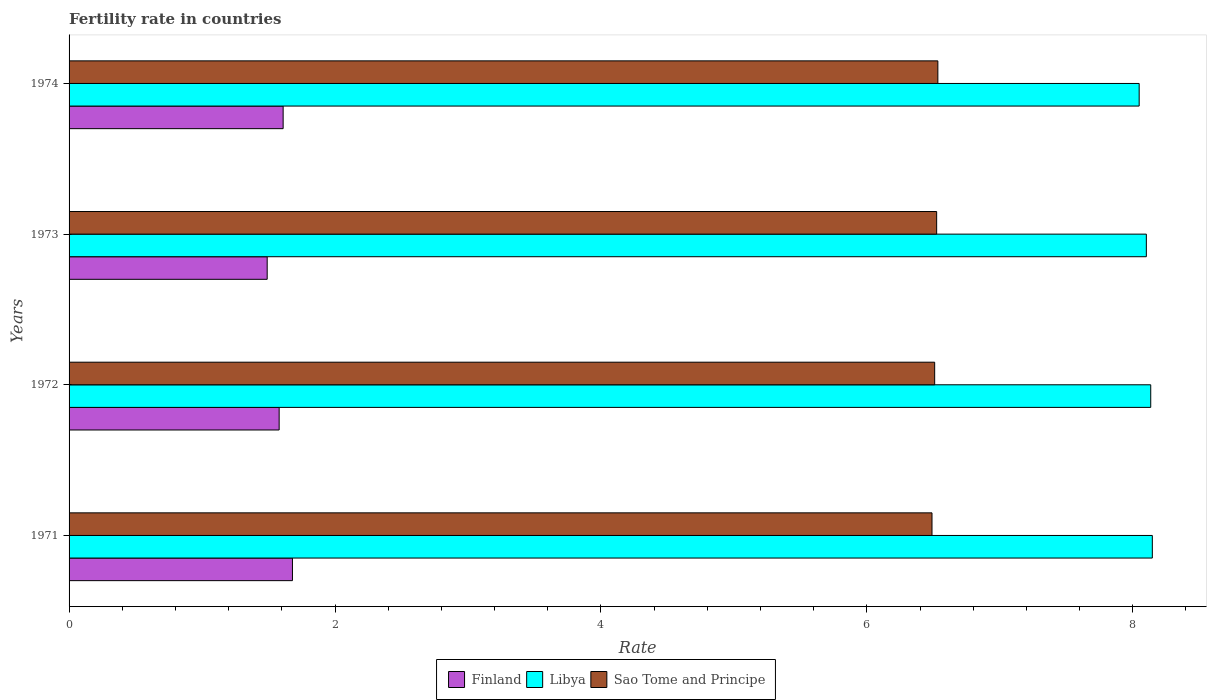Are the number of bars per tick equal to the number of legend labels?
Offer a very short reply. Yes. How many bars are there on the 4th tick from the top?
Make the answer very short. 3. What is the label of the 1st group of bars from the top?
Your answer should be compact. 1974. What is the fertility rate in Finland in 1974?
Your response must be concise. 1.61. Across all years, what is the maximum fertility rate in Sao Tome and Principe?
Give a very brief answer. 6.53. Across all years, what is the minimum fertility rate in Finland?
Keep it short and to the point. 1.49. In which year was the fertility rate in Sao Tome and Principe maximum?
Your answer should be very brief. 1974. In which year was the fertility rate in Sao Tome and Principe minimum?
Your answer should be compact. 1971. What is the total fertility rate in Sao Tome and Principe in the graph?
Ensure brevity in your answer.  26.06. What is the difference between the fertility rate in Libya in 1972 and that in 1974?
Offer a terse response. 0.09. What is the difference between the fertility rate in Libya in 1971 and the fertility rate in Sao Tome and Principe in 1973?
Your answer should be compact. 1.62. What is the average fertility rate in Finland per year?
Provide a succinct answer. 1.59. In the year 1971, what is the difference between the fertility rate in Sao Tome and Principe and fertility rate in Finland?
Your response must be concise. 4.81. In how many years, is the fertility rate in Libya greater than 8 ?
Your answer should be very brief. 4. What is the ratio of the fertility rate in Libya in 1973 to that in 1974?
Your response must be concise. 1.01. Is the fertility rate in Sao Tome and Principe in 1973 less than that in 1974?
Your answer should be very brief. Yes. Is the difference between the fertility rate in Sao Tome and Principe in 1972 and 1974 greater than the difference between the fertility rate in Finland in 1972 and 1974?
Offer a terse response. Yes. What is the difference between the highest and the second highest fertility rate in Sao Tome and Principe?
Keep it short and to the point. 0.01. What is the difference between the highest and the lowest fertility rate in Libya?
Offer a terse response. 0.1. Is the sum of the fertility rate in Libya in 1973 and 1974 greater than the maximum fertility rate in Sao Tome and Principe across all years?
Keep it short and to the point. Yes. What does the 2nd bar from the top in 1973 represents?
Give a very brief answer. Libya. What does the 3rd bar from the bottom in 1974 represents?
Provide a succinct answer. Sao Tome and Principe. Are all the bars in the graph horizontal?
Your answer should be very brief. Yes. How many years are there in the graph?
Your answer should be compact. 4. Does the graph contain grids?
Offer a very short reply. No. Where does the legend appear in the graph?
Keep it short and to the point. Bottom center. How are the legend labels stacked?
Provide a succinct answer. Horizontal. What is the title of the graph?
Provide a short and direct response. Fertility rate in countries. Does "Germany" appear as one of the legend labels in the graph?
Offer a very short reply. No. What is the label or title of the X-axis?
Offer a terse response. Rate. What is the Rate of Finland in 1971?
Offer a terse response. 1.68. What is the Rate of Libya in 1971?
Keep it short and to the point. 8.15. What is the Rate of Sao Tome and Principe in 1971?
Ensure brevity in your answer.  6.49. What is the Rate in Finland in 1972?
Your response must be concise. 1.58. What is the Rate of Libya in 1972?
Offer a terse response. 8.13. What is the Rate in Sao Tome and Principe in 1972?
Offer a very short reply. 6.51. What is the Rate of Finland in 1973?
Provide a short and direct response. 1.49. What is the Rate in Libya in 1973?
Provide a short and direct response. 8.1. What is the Rate in Sao Tome and Principe in 1973?
Your answer should be compact. 6.53. What is the Rate in Finland in 1974?
Make the answer very short. 1.61. What is the Rate in Libya in 1974?
Keep it short and to the point. 8.05. What is the Rate in Sao Tome and Principe in 1974?
Your response must be concise. 6.53. Across all years, what is the maximum Rate of Finland?
Offer a terse response. 1.68. Across all years, what is the maximum Rate of Libya?
Your answer should be compact. 8.15. Across all years, what is the maximum Rate in Sao Tome and Principe?
Offer a terse response. 6.53. Across all years, what is the minimum Rate in Finland?
Ensure brevity in your answer.  1.49. Across all years, what is the minimum Rate in Libya?
Provide a succinct answer. 8.05. Across all years, what is the minimum Rate of Sao Tome and Principe?
Give a very brief answer. 6.49. What is the total Rate of Finland in the graph?
Make the answer very short. 6.36. What is the total Rate of Libya in the graph?
Offer a terse response. 32.43. What is the total Rate in Sao Tome and Principe in the graph?
Offer a very short reply. 26.06. What is the difference between the Rate of Finland in 1971 and that in 1972?
Provide a succinct answer. 0.1. What is the difference between the Rate of Libya in 1971 and that in 1972?
Make the answer very short. 0.01. What is the difference between the Rate in Sao Tome and Principe in 1971 and that in 1972?
Your response must be concise. -0.02. What is the difference between the Rate in Finland in 1971 and that in 1973?
Offer a very short reply. 0.19. What is the difference between the Rate of Libya in 1971 and that in 1973?
Provide a short and direct response. 0.04. What is the difference between the Rate in Sao Tome and Principe in 1971 and that in 1973?
Your response must be concise. -0.04. What is the difference between the Rate in Finland in 1971 and that in 1974?
Give a very brief answer. 0.07. What is the difference between the Rate in Libya in 1971 and that in 1974?
Your answer should be compact. 0.1. What is the difference between the Rate of Sao Tome and Principe in 1971 and that in 1974?
Offer a terse response. -0.04. What is the difference between the Rate of Finland in 1972 and that in 1973?
Provide a succinct answer. 0.09. What is the difference between the Rate in Libya in 1972 and that in 1973?
Your response must be concise. 0.03. What is the difference between the Rate in Sao Tome and Principe in 1972 and that in 1973?
Your response must be concise. -0.01. What is the difference between the Rate of Finland in 1972 and that in 1974?
Offer a terse response. -0.03. What is the difference between the Rate of Libya in 1972 and that in 1974?
Offer a very short reply. 0.09. What is the difference between the Rate in Sao Tome and Principe in 1972 and that in 1974?
Provide a succinct answer. -0.02. What is the difference between the Rate of Finland in 1973 and that in 1974?
Give a very brief answer. -0.12. What is the difference between the Rate of Libya in 1973 and that in 1974?
Offer a very short reply. 0.05. What is the difference between the Rate in Sao Tome and Principe in 1973 and that in 1974?
Offer a very short reply. -0.01. What is the difference between the Rate in Finland in 1971 and the Rate in Libya in 1972?
Your answer should be very brief. -6.46. What is the difference between the Rate in Finland in 1971 and the Rate in Sao Tome and Principe in 1972?
Your response must be concise. -4.83. What is the difference between the Rate of Libya in 1971 and the Rate of Sao Tome and Principe in 1972?
Your answer should be very brief. 1.64. What is the difference between the Rate of Finland in 1971 and the Rate of Libya in 1973?
Ensure brevity in your answer.  -6.42. What is the difference between the Rate in Finland in 1971 and the Rate in Sao Tome and Principe in 1973?
Your response must be concise. -4.84. What is the difference between the Rate of Libya in 1971 and the Rate of Sao Tome and Principe in 1973?
Provide a short and direct response. 1.62. What is the difference between the Rate of Finland in 1971 and the Rate of Libya in 1974?
Make the answer very short. -6.37. What is the difference between the Rate of Finland in 1971 and the Rate of Sao Tome and Principe in 1974?
Make the answer very short. -4.85. What is the difference between the Rate of Libya in 1971 and the Rate of Sao Tome and Principe in 1974?
Keep it short and to the point. 1.61. What is the difference between the Rate in Finland in 1972 and the Rate in Libya in 1973?
Ensure brevity in your answer.  -6.52. What is the difference between the Rate of Finland in 1972 and the Rate of Sao Tome and Principe in 1973?
Offer a very short reply. -4.95. What is the difference between the Rate in Libya in 1972 and the Rate in Sao Tome and Principe in 1973?
Offer a very short reply. 1.61. What is the difference between the Rate in Finland in 1972 and the Rate in Libya in 1974?
Give a very brief answer. -6.47. What is the difference between the Rate of Finland in 1972 and the Rate of Sao Tome and Principe in 1974?
Your answer should be compact. -4.95. What is the difference between the Rate in Libya in 1972 and the Rate in Sao Tome and Principe in 1974?
Ensure brevity in your answer.  1.6. What is the difference between the Rate in Finland in 1973 and the Rate in Libya in 1974?
Keep it short and to the point. -6.56. What is the difference between the Rate of Finland in 1973 and the Rate of Sao Tome and Principe in 1974?
Offer a very short reply. -5.04. What is the difference between the Rate in Libya in 1973 and the Rate in Sao Tome and Principe in 1974?
Ensure brevity in your answer.  1.57. What is the average Rate in Finland per year?
Give a very brief answer. 1.59. What is the average Rate in Libya per year?
Your answer should be very brief. 8.11. What is the average Rate of Sao Tome and Principe per year?
Your response must be concise. 6.51. In the year 1971, what is the difference between the Rate of Finland and Rate of Libya?
Ensure brevity in your answer.  -6.47. In the year 1971, what is the difference between the Rate in Finland and Rate in Sao Tome and Principe?
Make the answer very short. -4.81. In the year 1971, what is the difference between the Rate of Libya and Rate of Sao Tome and Principe?
Provide a succinct answer. 1.66. In the year 1972, what is the difference between the Rate of Finland and Rate of Libya?
Offer a terse response. -6.55. In the year 1972, what is the difference between the Rate of Finland and Rate of Sao Tome and Principe?
Give a very brief answer. -4.93. In the year 1972, what is the difference between the Rate in Libya and Rate in Sao Tome and Principe?
Make the answer very short. 1.62. In the year 1973, what is the difference between the Rate of Finland and Rate of Libya?
Offer a very short reply. -6.61. In the year 1973, what is the difference between the Rate in Finland and Rate in Sao Tome and Principe?
Your answer should be compact. -5.04. In the year 1973, what is the difference between the Rate of Libya and Rate of Sao Tome and Principe?
Give a very brief answer. 1.58. In the year 1974, what is the difference between the Rate of Finland and Rate of Libya?
Give a very brief answer. -6.44. In the year 1974, what is the difference between the Rate in Finland and Rate in Sao Tome and Principe?
Ensure brevity in your answer.  -4.92. In the year 1974, what is the difference between the Rate of Libya and Rate of Sao Tome and Principe?
Your answer should be compact. 1.51. What is the ratio of the Rate in Finland in 1971 to that in 1972?
Your answer should be compact. 1.06. What is the ratio of the Rate in Libya in 1971 to that in 1972?
Make the answer very short. 1. What is the ratio of the Rate of Finland in 1971 to that in 1973?
Ensure brevity in your answer.  1.13. What is the ratio of the Rate of Libya in 1971 to that in 1973?
Offer a terse response. 1.01. What is the ratio of the Rate of Finland in 1971 to that in 1974?
Offer a terse response. 1.04. What is the ratio of the Rate of Libya in 1971 to that in 1974?
Make the answer very short. 1.01. What is the ratio of the Rate of Sao Tome and Principe in 1971 to that in 1974?
Your answer should be very brief. 0.99. What is the ratio of the Rate in Finland in 1972 to that in 1973?
Offer a terse response. 1.06. What is the ratio of the Rate of Libya in 1972 to that in 1973?
Give a very brief answer. 1. What is the ratio of the Rate of Finland in 1972 to that in 1974?
Make the answer very short. 0.98. What is the ratio of the Rate of Libya in 1972 to that in 1974?
Make the answer very short. 1.01. What is the ratio of the Rate of Finland in 1973 to that in 1974?
Offer a very short reply. 0.93. What is the ratio of the Rate in Libya in 1973 to that in 1974?
Provide a short and direct response. 1.01. What is the difference between the highest and the second highest Rate of Finland?
Your answer should be compact. 0.07. What is the difference between the highest and the second highest Rate of Libya?
Provide a succinct answer. 0.01. What is the difference between the highest and the second highest Rate of Sao Tome and Principe?
Your response must be concise. 0.01. What is the difference between the highest and the lowest Rate of Finland?
Ensure brevity in your answer.  0.19. What is the difference between the highest and the lowest Rate of Libya?
Your response must be concise. 0.1. What is the difference between the highest and the lowest Rate in Sao Tome and Principe?
Offer a very short reply. 0.04. 